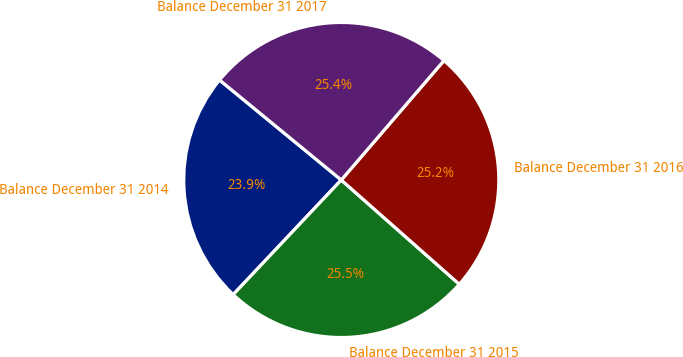<chart> <loc_0><loc_0><loc_500><loc_500><pie_chart><fcel>Balance December 31 2014<fcel>Balance December 31 2015<fcel>Balance December 31 2016<fcel>Balance December 31 2017<nl><fcel>23.91%<fcel>25.52%<fcel>25.21%<fcel>25.36%<nl></chart> 